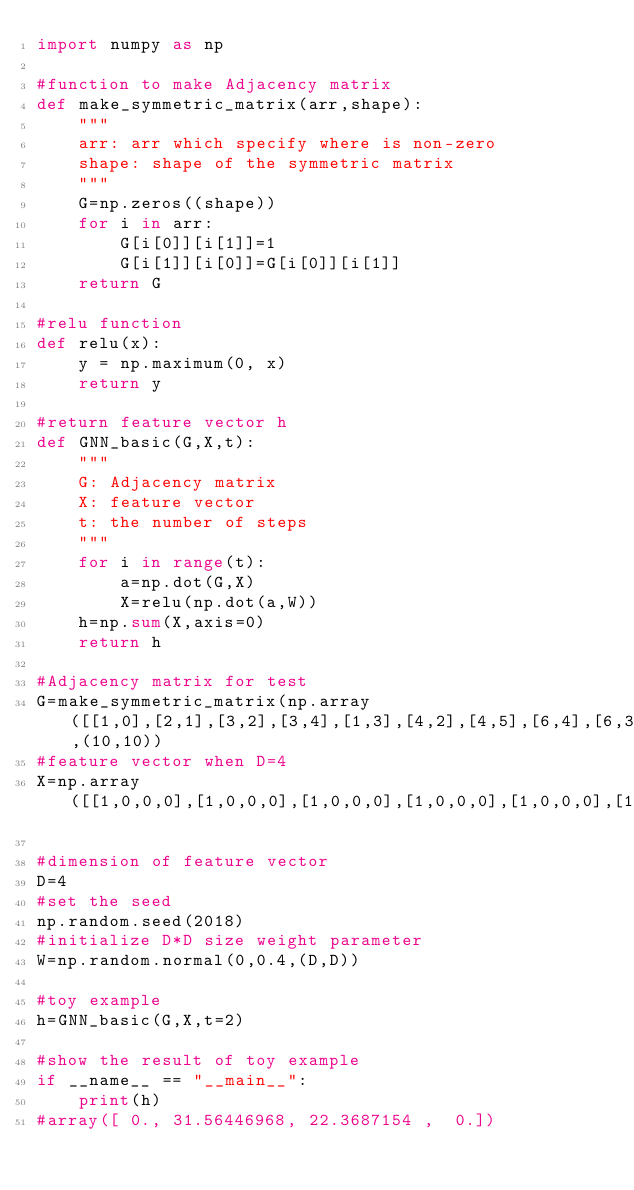<code> <loc_0><loc_0><loc_500><loc_500><_Python_>import numpy as np

#function to make Adjacency matrix
def make_symmetric_matrix(arr,shape):
    """
    arr: arr which specify where is non-zero
    shape: shape of the symmetric matrix
    """
    G=np.zeros((shape))
    for i in arr:
        G[i[0]][i[1]]=1
        G[i[1]][i[0]]=G[i[0]][i[1]]
    return G

#relu function 
def relu(x):
    y = np.maximum(0, x)
    return y

#return feature vector h
def GNN_basic(G,X,t):
    """
    G: Adjacency matrix
    X: feature vector 
    t: the number of steps
    """
    for i in range(t):
        a=np.dot(G,X)
        X=relu(np.dot(a,W))
    h=np.sum(X,axis=0)
    return h

#Adjacency matrix for test
G=make_symmetric_matrix(np.array([[1,0],[2,1],[3,2],[3,4],[1,3],[4,2],[4,5],[6,4],[6,3],[6,5],[7,2],[7,0],[7,3],[8,0],[8,5],[8,6],[9,2],[9,8]]),(10,10))
#feature vector when D=4
X=np.array([[1,0,0,0],[1,0,0,0],[1,0,0,0],[1,0,0,0],[1,0,0,0],[1,0,0,0],[1,0,0,0],[1,0,0,0],[1,0,0,0],[1,0,0,0]])

#dimension of feature vector 
D=4
#set the seed
np.random.seed(2018)
#initialize D*D size weight parameter 
W=np.random.normal(0,0.4,(D,D))

#toy example
h=GNN_basic(G,X,t=2)

#show the result of toy example 
if __name__ == "__main__":
    print(h)
#array([ 0., 31.56446968, 22.3687154 ,  0.])</code> 